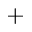<formula> <loc_0><loc_0><loc_500><loc_500>^ { + }</formula> 